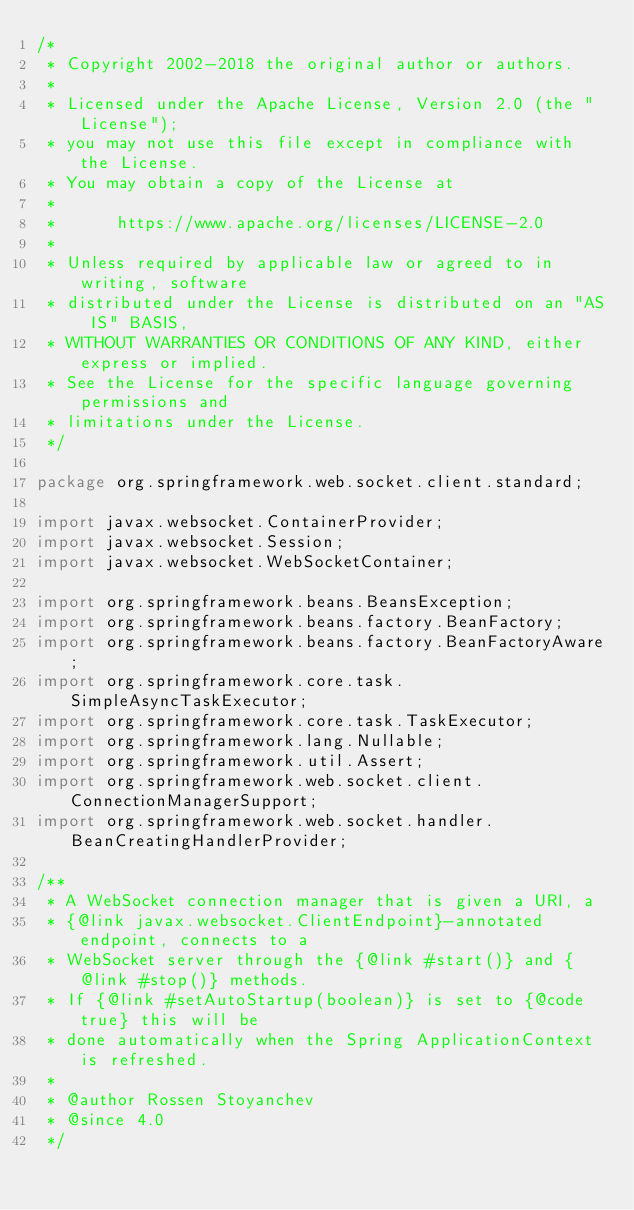<code> <loc_0><loc_0><loc_500><loc_500><_Java_>/*
 * Copyright 2002-2018 the original author or authors.
 *
 * Licensed under the Apache License, Version 2.0 (the "License");
 * you may not use this file except in compliance with the License.
 * You may obtain a copy of the License at
 *
 *      https://www.apache.org/licenses/LICENSE-2.0
 *
 * Unless required by applicable law or agreed to in writing, software
 * distributed under the License is distributed on an "AS IS" BASIS,
 * WITHOUT WARRANTIES OR CONDITIONS OF ANY KIND, either express or implied.
 * See the License for the specific language governing permissions and
 * limitations under the License.
 */

package org.springframework.web.socket.client.standard;

import javax.websocket.ContainerProvider;
import javax.websocket.Session;
import javax.websocket.WebSocketContainer;

import org.springframework.beans.BeansException;
import org.springframework.beans.factory.BeanFactory;
import org.springframework.beans.factory.BeanFactoryAware;
import org.springframework.core.task.SimpleAsyncTaskExecutor;
import org.springframework.core.task.TaskExecutor;
import org.springframework.lang.Nullable;
import org.springframework.util.Assert;
import org.springframework.web.socket.client.ConnectionManagerSupport;
import org.springframework.web.socket.handler.BeanCreatingHandlerProvider;

/**
 * A WebSocket connection manager that is given a URI, a
 * {@link javax.websocket.ClientEndpoint}-annotated endpoint, connects to a
 * WebSocket server through the {@link #start()} and {@link #stop()} methods.
 * If {@link #setAutoStartup(boolean)} is set to {@code true} this will be
 * done automatically when the Spring ApplicationContext is refreshed.
 *
 * @author Rossen Stoyanchev
 * @since 4.0
 */</code> 